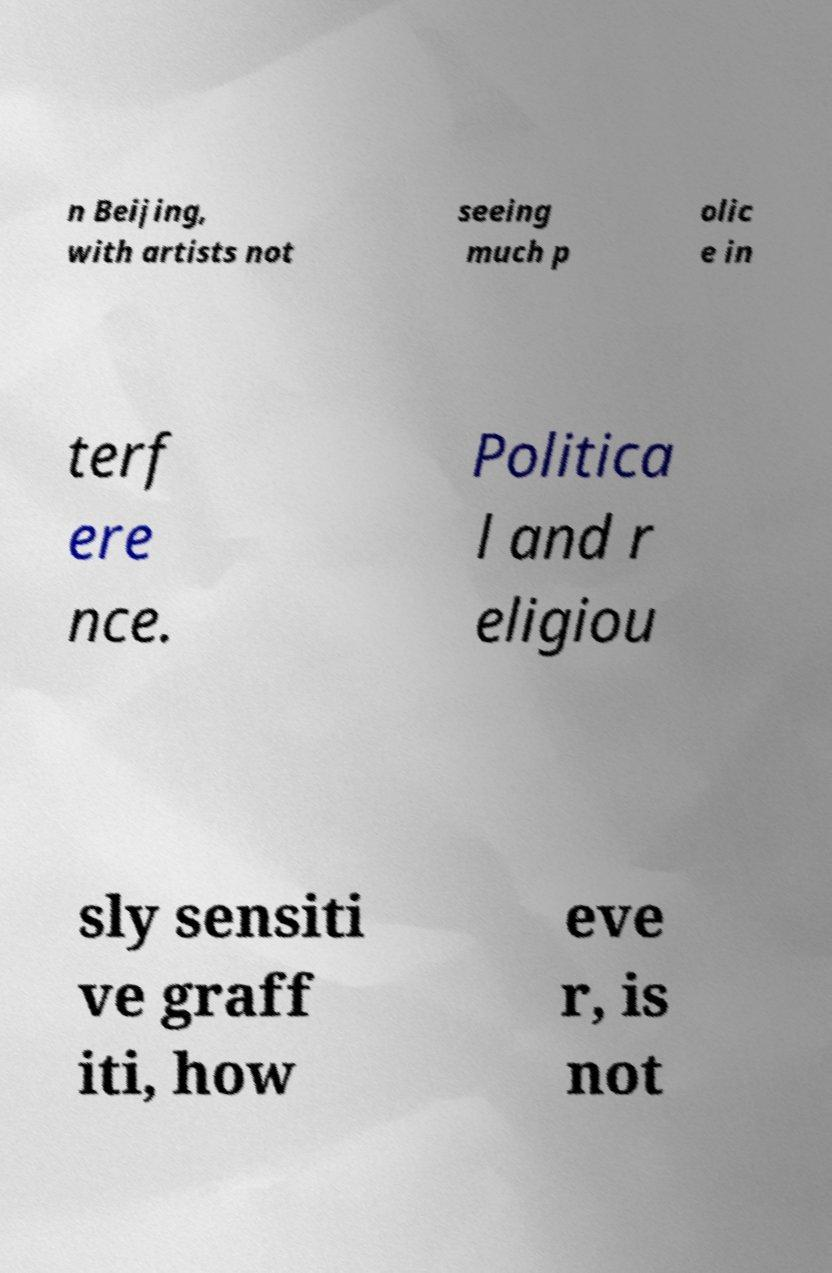Can you read and provide the text displayed in the image?This photo seems to have some interesting text. Can you extract and type it out for me? n Beijing, with artists not seeing much p olic e in terf ere nce. Politica l and r eligiou sly sensiti ve graff iti, how eve r, is not 